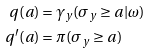<formula> <loc_0><loc_0><loc_500><loc_500>q ( a ) & = \gamma _ { y } ( \sigma _ { y } \geq a | \omega ) \\ q ^ { \prime } ( a ) & = \pi ( \sigma _ { y } \geq a ) \\</formula> 